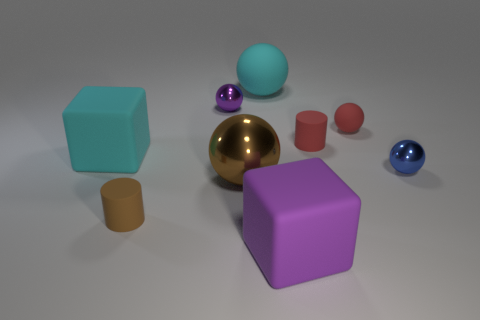The large cyan rubber thing behind the tiny purple metallic sphere has what shape?
Provide a succinct answer. Sphere. Is the blue sphere made of the same material as the tiny purple thing?
Your answer should be compact. Yes. There is a brown metallic sphere; what number of red balls are behind it?
Offer a terse response. 1. There is a cyan rubber object that is to the left of the brown object in front of the brown metal thing; what is its shape?
Your answer should be very brief. Cube. Are there more shiny balls that are on the left side of the big shiny sphere than big blue cylinders?
Offer a very short reply. Yes. There is a brown rubber thing in front of the cyan matte cube; how many large purple objects are behind it?
Provide a short and direct response. 0. There is a big cyan rubber thing that is on the right side of the large sphere in front of the big cyan thing that is in front of the tiny red cylinder; what is its shape?
Provide a succinct answer. Sphere. What is the size of the brown rubber cylinder?
Provide a succinct answer. Small. Are there any red things made of the same material as the small purple object?
Make the answer very short. No. What size is the red rubber object that is the same shape as the tiny blue object?
Your answer should be compact. Small. 